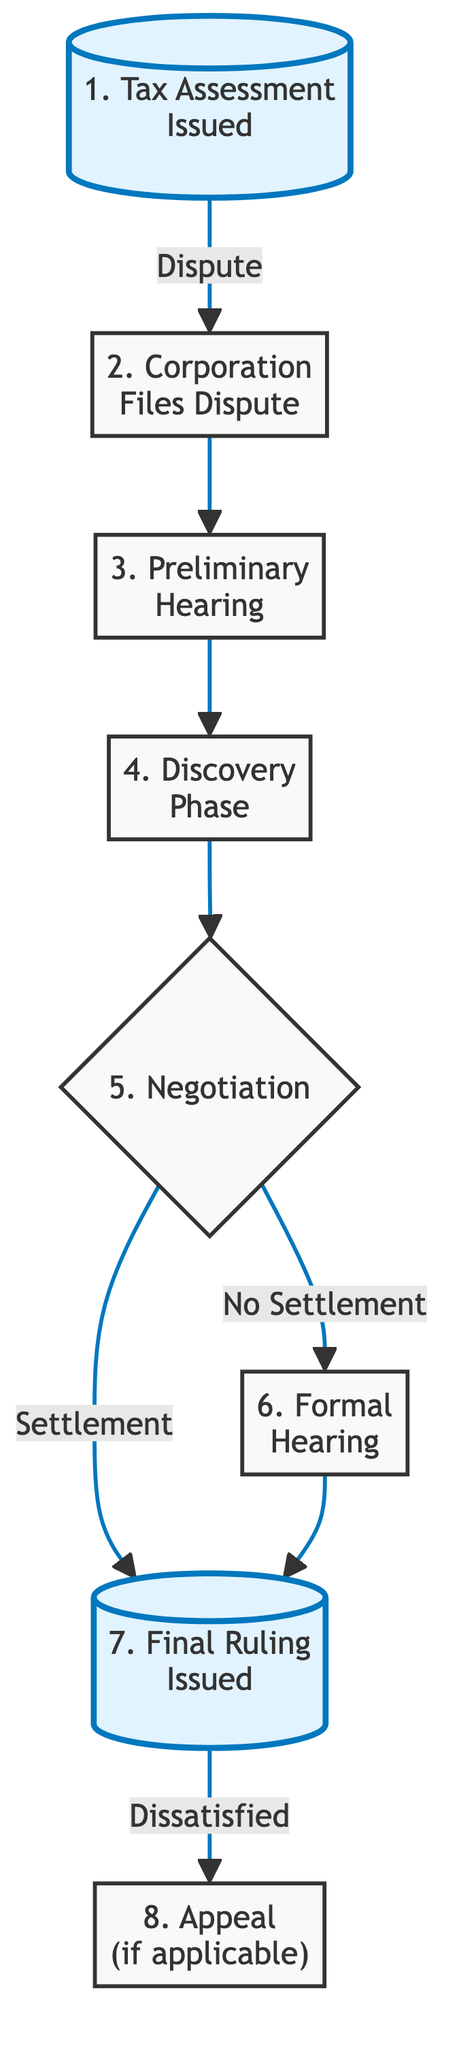What is the first step in the tax dispute resolution process? The diagram indicates that the first step is labeled "1. Tax Assessment Issued," which denotes the starting point of the process.
Answer: Tax Assessment Issued How many nodes are present in the diagram? By counting the elements in the diagram, there are eight labeled nodes representing different stages of the dispute resolution process.
Answer: 8 What is the last step before a final ruling is issued? According to the diagram, the last step preceding a final ruling is the "6. Formal Hearing," which occurs directly before the final ruling node.
Answer: Formal Hearing Which decision point leads to either a settlement or a formal hearing? The decision point labeled "5. Negotiation" directs the flow to either settlement or proceeding to a formal hearing based on the outcome of efforts to negotiate.
Answer: Negotiation If a party is dissatisfied with the final ruling, what is the next step? The diagram specifies that if either party is dissatisfied after the final ruling, they may proceed to "8. Appeal (if applicable)," indicating the option to contest the ruling.
Answer: Appeal What step follows the discovery phase? The flowchart indicates that after the "4. Discovery Phase," the next step is the "5. Negotiation," which is where the parties discuss possible settlements.
Answer: Negotiation Which nodes are highlighted in the flowchart? The highlighted nodes in the diagram are "1. Tax Assessment Issued" and "7. Final Ruling Issued," emphasizing the start and conclusion of the dispute process.
Answer: Tax Assessment Issued; Final Ruling Issued What action is taken by the corporation at the second step? The diagram shows that at the second step, the corporation takes the action to file a formal dispute against the tax assessment issued by the tax authority.
Answer: Corporation Files Dispute 